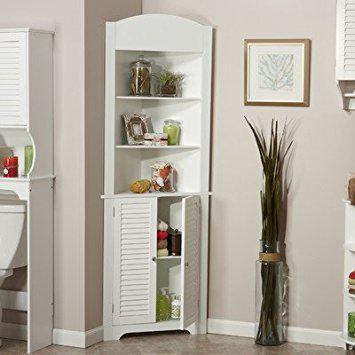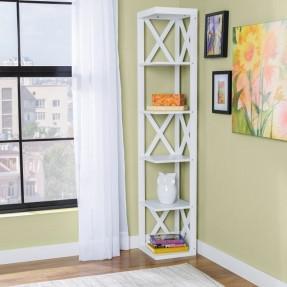The first image is the image on the left, the second image is the image on the right. For the images displayed, is the sentence "A corner shelf unit is next to a window with long white drapes" factually correct? Answer yes or no. Yes. The first image is the image on the left, the second image is the image on the right. Analyze the images presented: Is the assertion "An image shows a right-angle white corner cabinet, with a solid back and five shelves." valid? Answer yes or no. Yes. 